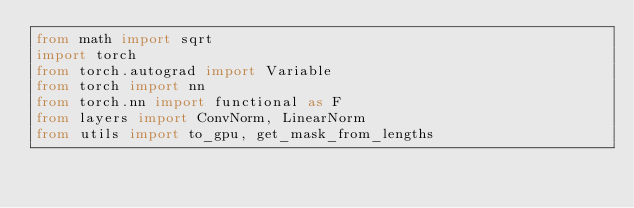<code> <loc_0><loc_0><loc_500><loc_500><_Python_>from math import sqrt
import torch
from torch.autograd import Variable
from torch import nn
from torch.nn import functional as F
from layers import ConvNorm, LinearNorm
from utils import to_gpu, get_mask_from_lengths

</code> 